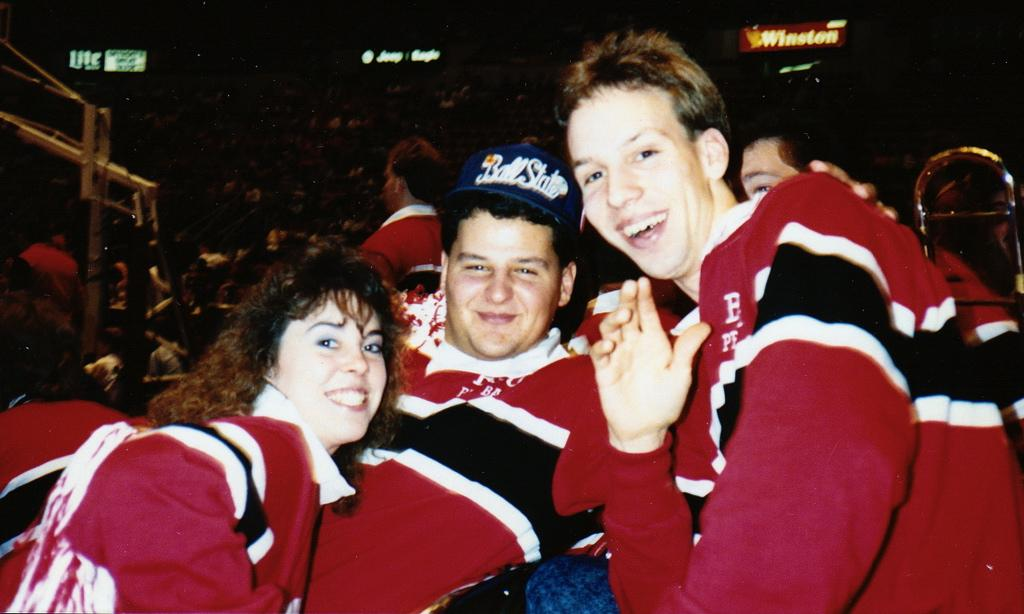How many people are in the image? There are three persons in the image. What is the person in the center wearing? The person in the center is wearing a cap. Can you describe the background of the image? There are many people in the background of the image. What type of signage is present in the image? There are name boards with light in the image. What type of patch can be seen on the stranger's nose in the image? There is no stranger present in the image, and therefore no patch can be seen on anyone's nose. 